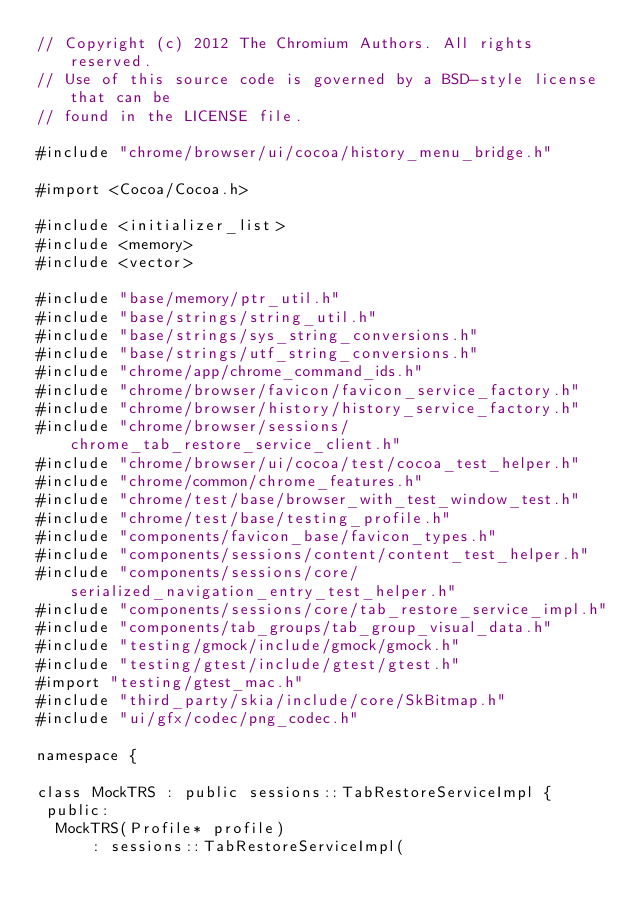<code> <loc_0><loc_0><loc_500><loc_500><_ObjectiveC_>// Copyright (c) 2012 The Chromium Authors. All rights reserved.
// Use of this source code is governed by a BSD-style license that can be
// found in the LICENSE file.

#include "chrome/browser/ui/cocoa/history_menu_bridge.h"

#import <Cocoa/Cocoa.h>

#include <initializer_list>
#include <memory>
#include <vector>

#include "base/memory/ptr_util.h"
#include "base/strings/string_util.h"
#include "base/strings/sys_string_conversions.h"
#include "base/strings/utf_string_conversions.h"
#include "chrome/app/chrome_command_ids.h"
#include "chrome/browser/favicon/favicon_service_factory.h"
#include "chrome/browser/history/history_service_factory.h"
#include "chrome/browser/sessions/chrome_tab_restore_service_client.h"
#include "chrome/browser/ui/cocoa/test/cocoa_test_helper.h"
#include "chrome/common/chrome_features.h"
#include "chrome/test/base/browser_with_test_window_test.h"
#include "chrome/test/base/testing_profile.h"
#include "components/favicon_base/favicon_types.h"
#include "components/sessions/content/content_test_helper.h"
#include "components/sessions/core/serialized_navigation_entry_test_helper.h"
#include "components/sessions/core/tab_restore_service_impl.h"
#include "components/tab_groups/tab_group_visual_data.h"
#include "testing/gmock/include/gmock/gmock.h"
#include "testing/gtest/include/gtest/gtest.h"
#import "testing/gtest_mac.h"
#include "third_party/skia/include/core/SkBitmap.h"
#include "ui/gfx/codec/png_codec.h"

namespace {

class MockTRS : public sessions::TabRestoreServiceImpl {
 public:
  MockTRS(Profile* profile)
      : sessions::TabRestoreServiceImpl(</code> 